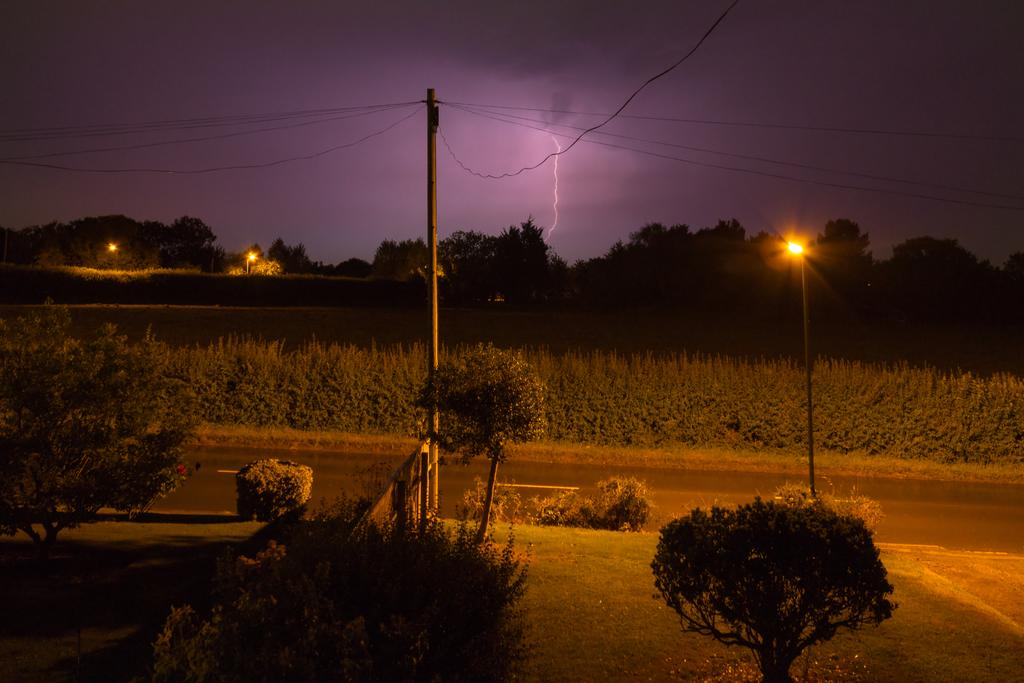What type of living organisms can be seen in the image? Plants are visible in the image. What type of infrastructure can be seen in the image? There is a road, street lights, current poles, and wires in the image. What can be seen in the background of the image? Trees and the sky are visible in the background of the image. What is the condition of the sky in the image? The sky appears to be lightning in the image. What type of payment is required to enter the scene in the image? There is no scene or requirement for payment in the image; it features plants, a road, street lights, current poles, wires, trees, and a lightning sky. Can you identify the actor in the image? There is no actor present in the image. 